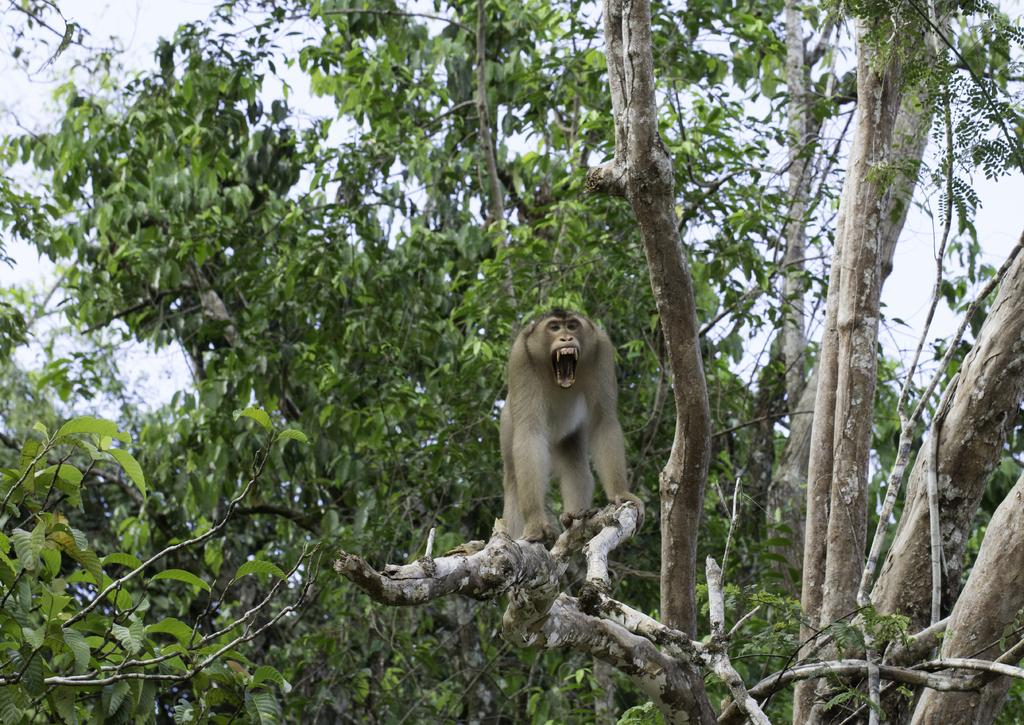What type of animal is in the image? There is a monkey in the image. Where is the monkey located in the image? The monkey is on a branch. What type of vegetation is visible in the image? There are trees visible in the image. What is visible in the background of the image? The sky is visible in the image. What type of ink is the monkey using to write its thoughts in the image? There is no ink or writing present in the image; it features a monkey on a branch. 